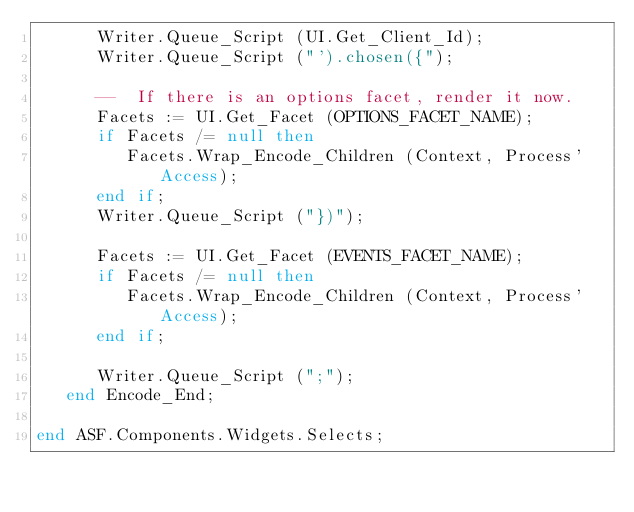Convert code to text. <code><loc_0><loc_0><loc_500><loc_500><_Ada_>      Writer.Queue_Script (UI.Get_Client_Id);
      Writer.Queue_Script ("').chosen({");

      --  If there is an options facet, render it now.
      Facets := UI.Get_Facet (OPTIONS_FACET_NAME);
      if Facets /= null then
         Facets.Wrap_Encode_Children (Context, Process'Access);
      end if;
      Writer.Queue_Script ("})");

      Facets := UI.Get_Facet (EVENTS_FACET_NAME);
      if Facets /= null then
         Facets.Wrap_Encode_Children (Context, Process'Access);
      end if;

      Writer.Queue_Script (";");
   end Encode_End;

end ASF.Components.Widgets.Selects;
</code> 